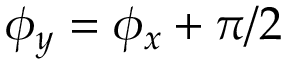<formula> <loc_0><loc_0><loc_500><loc_500>\phi _ { y } = \phi _ { x } + \pi / 2</formula> 